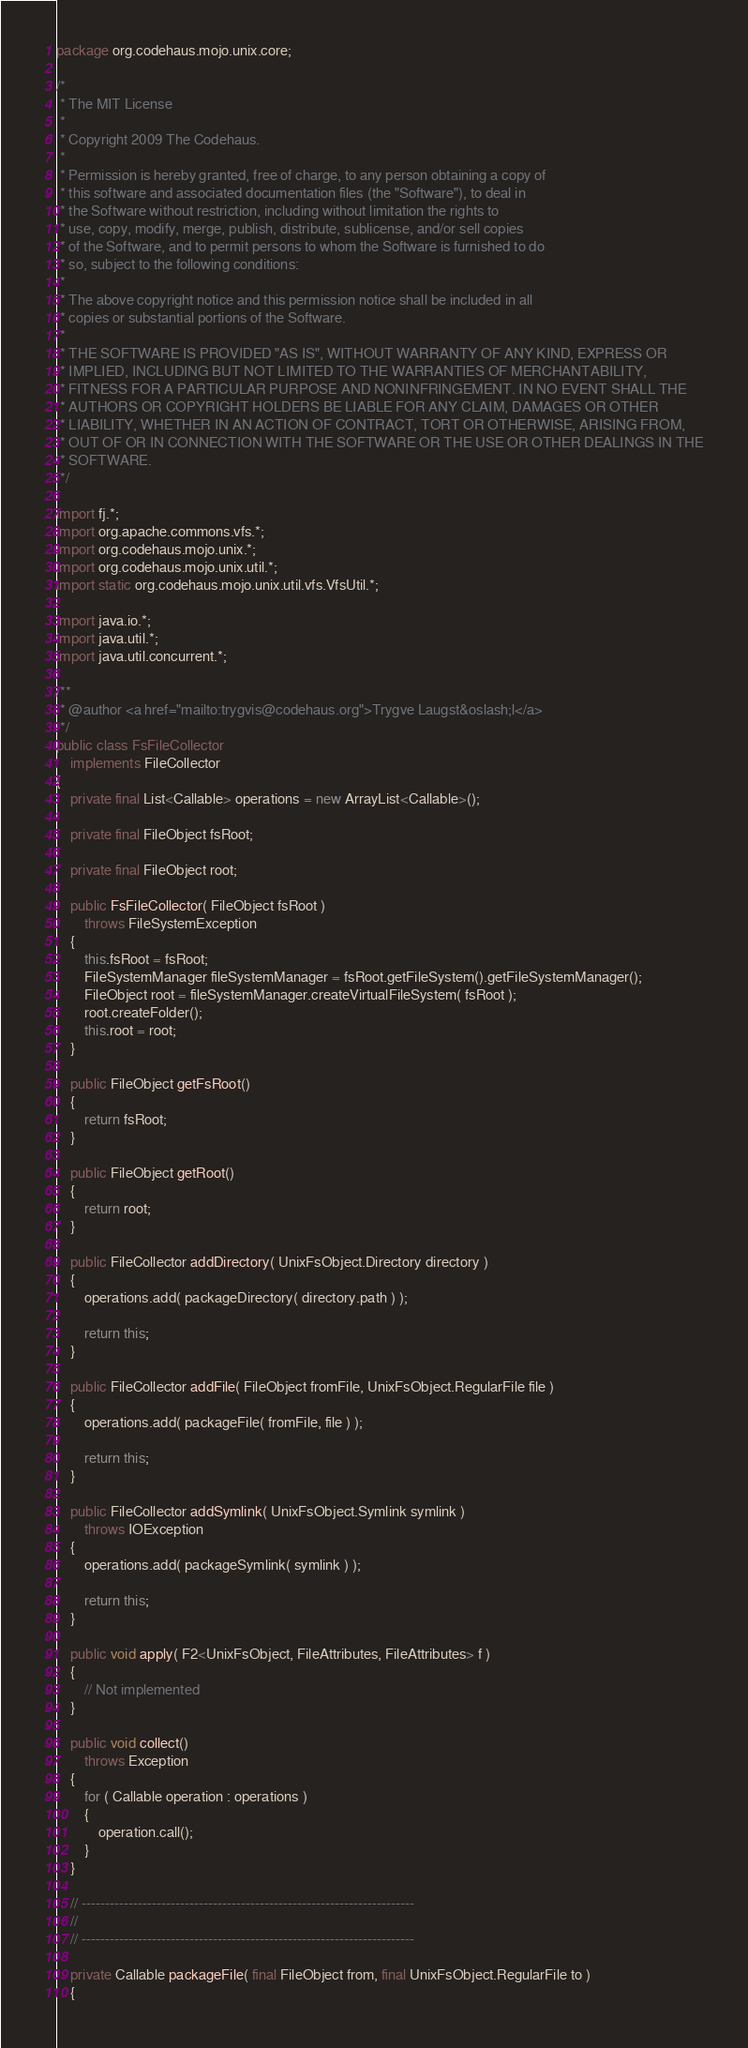Convert code to text. <code><loc_0><loc_0><loc_500><loc_500><_Java_>package org.codehaus.mojo.unix.core;

/*
 * The MIT License
 *
 * Copyright 2009 The Codehaus.
 *
 * Permission is hereby granted, free of charge, to any person obtaining a copy of
 * this software and associated documentation files (the "Software"), to deal in
 * the Software without restriction, including without limitation the rights to
 * use, copy, modify, merge, publish, distribute, sublicense, and/or sell copies
 * of the Software, and to permit persons to whom the Software is furnished to do
 * so, subject to the following conditions:
 *
 * The above copyright notice and this permission notice shall be included in all
 * copies or substantial portions of the Software.
 *
 * THE SOFTWARE IS PROVIDED "AS IS", WITHOUT WARRANTY OF ANY KIND, EXPRESS OR
 * IMPLIED, INCLUDING BUT NOT LIMITED TO THE WARRANTIES OF MERCHANTABILITY,
 * FITNESS FOR A PARTICULAR PURPOSE AND NONINFRINGEMENT. IN NO EVENT SHALL THE
 * AUTHORS OR COPYRIGHT HOLDERS BE LIABLE FOR ANY CLAIM, DAMAGES OR OTHER
 * LIABILITY, WHETHER IN AN ACTION OF CONTRACT, TORT OR OTHERWISE, ARISING FROM,
 * OUT OF OR IN CONNECTION WITH THE SOFTWARE OR THE USE OR OTHER DEALINGS IN THE
 * SOFTWARE.
 */

import fj.*;
import org.apache.commons.vfs.*;
import org.codehaus.mojo.unix.*;
import org.codehaus.mojo.unix.util.*;
import static org.codehaus.mojo.unix.util.vfs.VfsUtil.*;

import java.io.*;
import java.util.*;
import java.util.concurrent.*;

/**
 * @author <a href="mailto:trygvis@codehaus.org">Trygve Laugst&oslash;l</a>
 */
public class FsFileCollector
    implements FileCollector
{
    private final List<Callable> operations = new ArrayList<Callable>();

    private final FileObject fsRoot;

    private final FileObject root;

    public FsFileCollector( FileObject fsRoot )
        throws FileSystemException
    {
        this.fsRoot = fsRoot;
        FileSystemManager fileSystemManager = fsRoot.getFileSystem().getFileSystemManager();
        FileObject root = fileSystemManager.createVirtualFileSystem( fsRoot );
        root.createFolder();
        this.root = root;
    }

    public FileObject getFsRoot()
    {
        return fsRoot;
    }

    public FileObject getRoot()
    {
        return root;
    }

    public FileCollector addDirectory( UnixFsObject.Directory directory )
    {
        operations.add( packageDirectory( directory.path ) );

        return this;
    }

    public FileCollector addFile( FileObject fromFile, UnixFsObject.RegularFile file )
    {
        operations.add( packageFile( fromFile, file ) );

        return this;
    }

    public FileCollector addSymlink( UnixFsObject.Symlink symlink )
        throws IOException
    {
        operations.add( packageSymlink( symlink ) );

        return this;
    }

    public void apply( F2<UnixFsObject, FileAttributes, FileAttributes> f )
    {
        // Not implemented
    }

    public void collect()
        throws Exception
    {
        for ( Callable operation : operations )
        {
            operation.call();
        }
    }

    // -----------------------------------------------------------------------
    //
    // -----------------------------------------------------------------------

    private Callable packageFile( final FileObject from, final UnixFsObject.RegularFile to )
    {</code> 